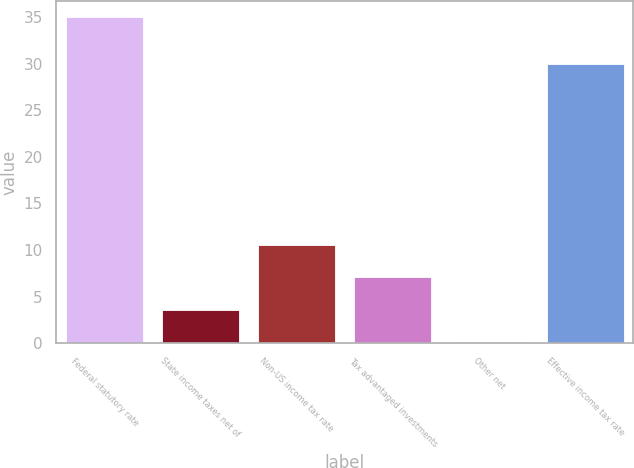Convert chart to OTSL. <chart><loc_0><loc_0><loc_500><loc_500><bar_chart><fcel>Federal statutory rate<fcel>State income taxes net of<fcel>Non-US income tax rate<fcel>Tax advantaged investments<fcel>Other net<fcel>Effective income tax rate<nl><fcel>35<fcel>3.59<fcel>10.57<fcel>7.08<fcel>0.1<fcel>30<nl></chart> 